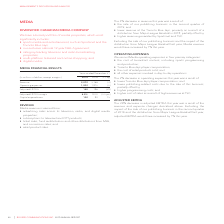According to Rogers Communications's financial document, What are one of the components of Media Revenue? advertising sales across its television, radio, and digital media properties. The document states: "REVENUE Media revenue is earned from: • advertising sales across its television, radio, and digital media properties; • subscriptions to televised and..." Also, What were the revenues in 2019 and 2018? The document shows two values: 2,072 and 2,168 (in millions). From the document: "Revenue 2,072 2,168 (4) Operating expenses 1,932 1,972 (2) Revenue 2,072 2,168 (4) Operating expenses 1,932 1,972 (2)..." Also, What was the percentage decrease in Adjusted EBITDA from 2018 to 2019? According to the financial document, 29%. The relevant text states: "ADJUSTED EBITDA The 29% decrease in adjusted EBITDA this year was a result of the revenue and expense changes described abov..." Also, can you calculate: What was the increase / (decrease) in revenue from 2018 to 2019? Based on the calculation: 2,072 - 2,168, the result is -96 (in millions). This is based on the information: "Revenue 2,072 2,168 (4) Operating expenses 1,932 1,972 (2) Revenue 2,072 2,168 (4) Operating expenses 1,932 1,972 (2)..." The key data points involved are: 2,072, 2,168. Also, can you calculate: What was the average Operating Expenses? To answer this question, I need to perform calculations using the financial data. The calculation is: (1,932 + 1,972) / 2, which equals 1952 (in millions). This is based on the information: "Revenue 2,072 2,168 (4) Operating expenses 1,932 1,972 (2) Revenue 2,072 2,168 (4) Operating expenses 1,932 1,972 (2)..." The key data points involved are: 1,932, 1,972. Also, can you calculate: What is the increase / (decrease) in Adjusted EBITDA from 2018 to 2019? Based on the calculation: 140 - 196, the result is -56 (in millions). This is based on the information: "Adjusted EBITDA 140 196 (29) Adjusted EBITDA 140 196 (29)..." The key data points involved are: 140, 196. 